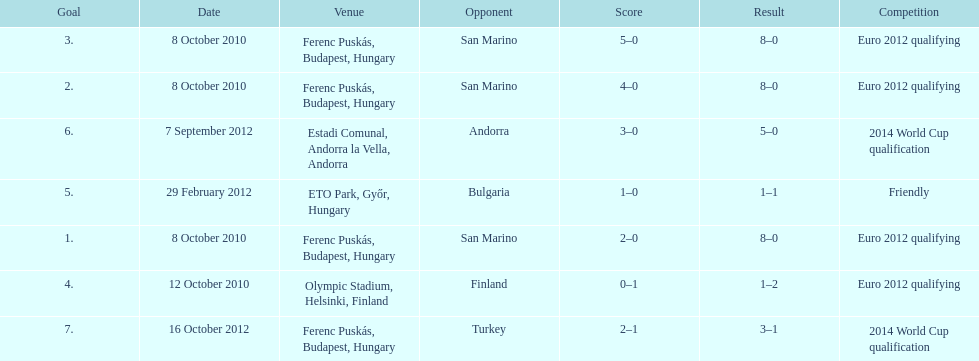How many consecutive games were goals were against san marino? 3. 